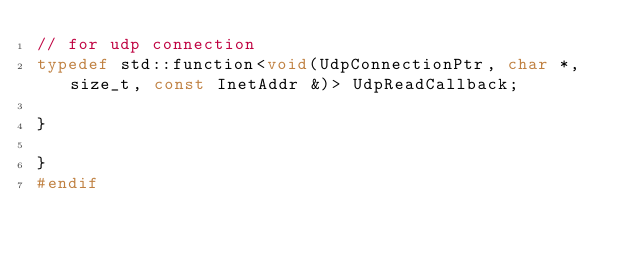Convert code to text. <code><loc_0><loc_0><loc_500><loc_500><_C_>// for udp connection
typedef std::function<void(UdpConnectionPtr, char *, size_t, const InetAddr &)> UdpReadCallback;

}

}
#endif
</code> 